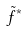Convert formula to latex. <formula><loc_0><loc_0><loc_500><loc_500>\tilde { f } ^ { * }</formula> 